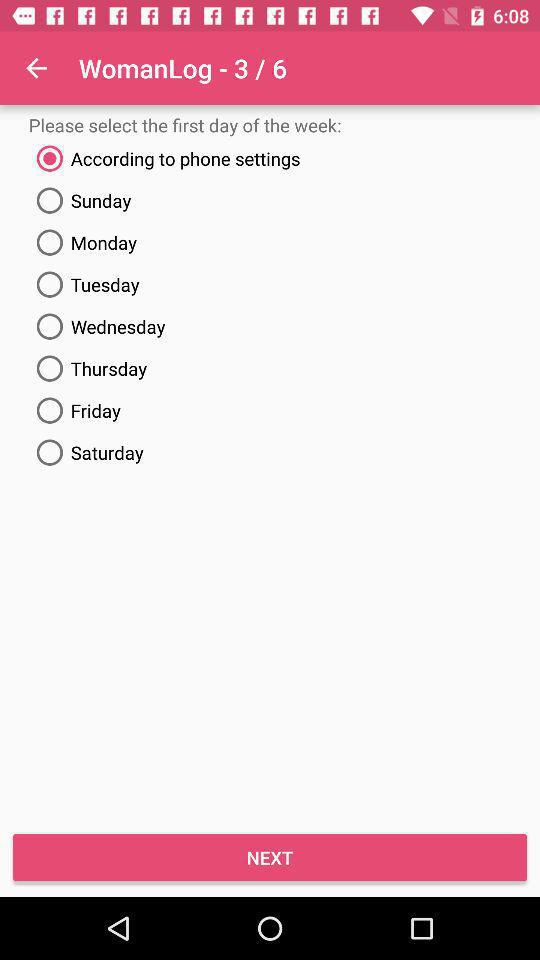Which option has been chosen? The chosen option is "According to phone settings". 